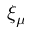<formula> <loc_0><loc_0><loc_500><loc_500>\xi _ { \mu }</formula> 